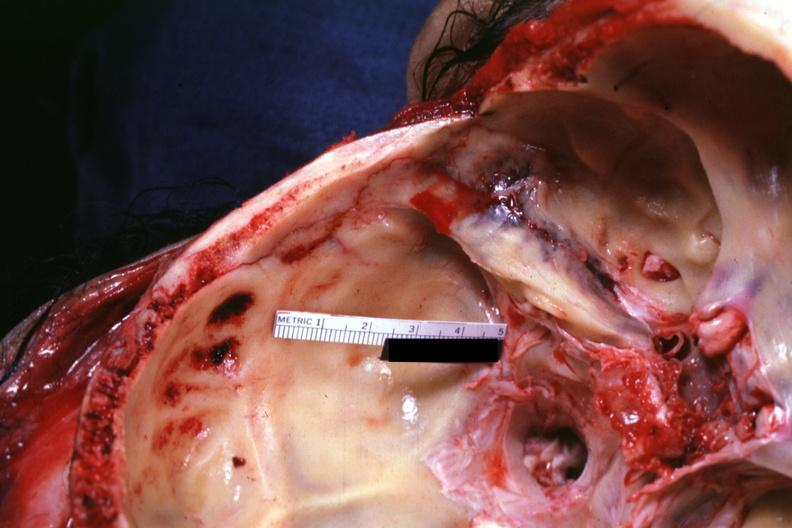what is present?
Answer the question using a single word or phrase. Basilar skull fracture 